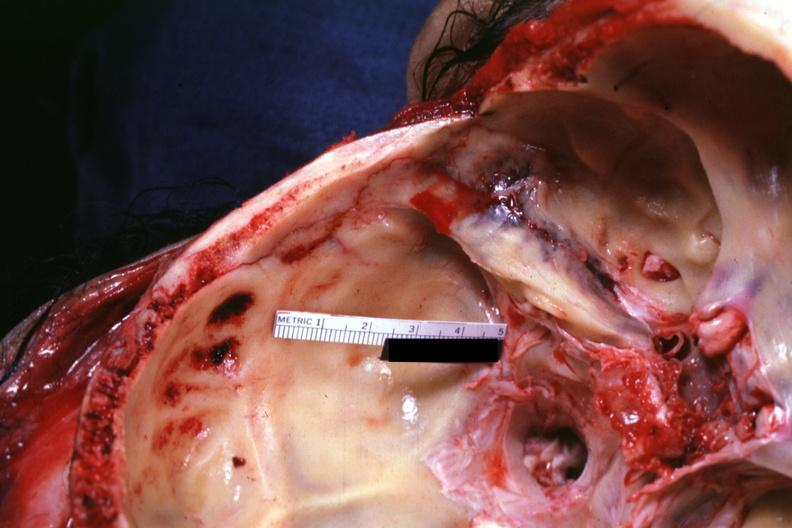what is present?
Answer the question using a single word or phrase. Basilar skull fracture 